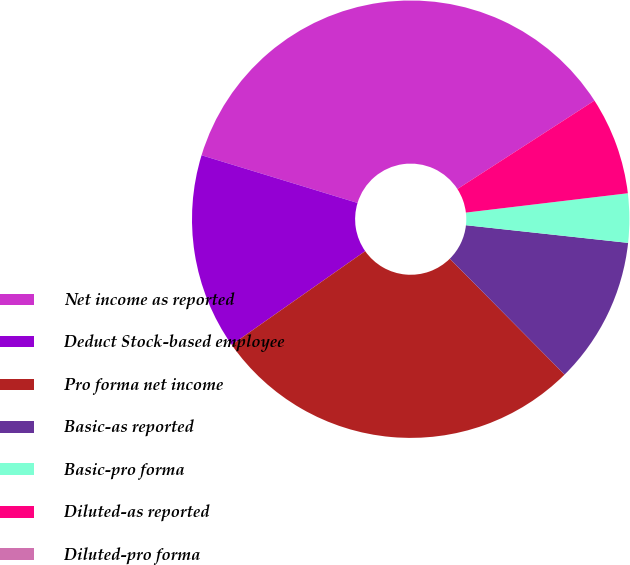<chart> <loc_0><loc_0><loc_500><loc_500><pie_chart><fcel>Net income as reported<fcel>Deduct Stock-based employee<fcel>Pro forma net income<fcel>Basic-as reported<fcel>Basic-pro forma<fcel>Diluted-as reported<fcel>Diluted-pro forma<nl><fcel>36.16%<fcel>14.46%<fcel>27.69%<fcel>10.85%<fcel>3.62%<fcel>7.23%<fcel>0.0%<nl></chart> 